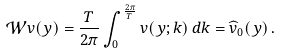<formula> <loc_0><loc_0><loc_500><loc_500>\mathcal { W } v ( y ) = \frac { T } { 2 \pi } \int _ { 0 } ^ { \frac { 2 \pi } { T } } v ( y ; k ) \, d k = \widehat { v } _ { 0 } ( y ) \, .</formula> 